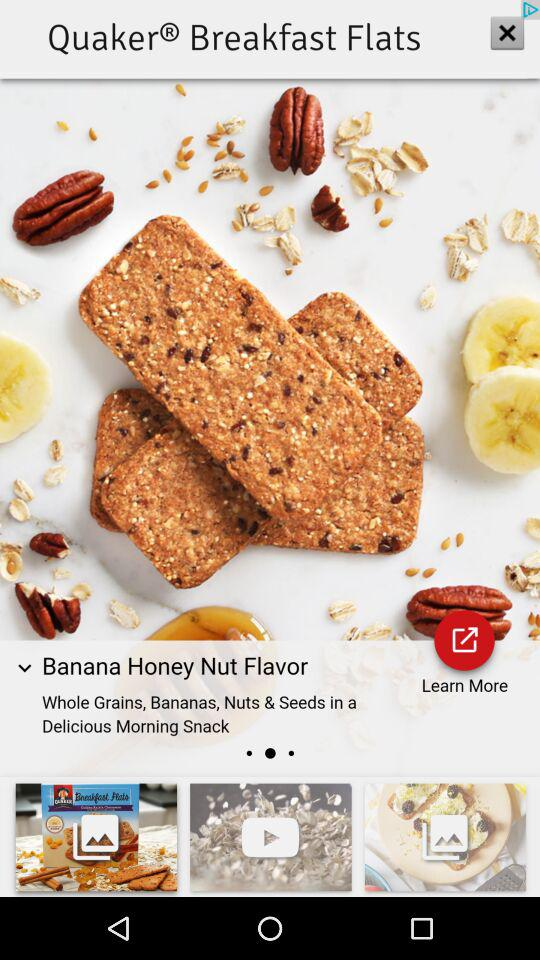How many items are in the gallery?
Answer the question using a single word or phrase. 3 